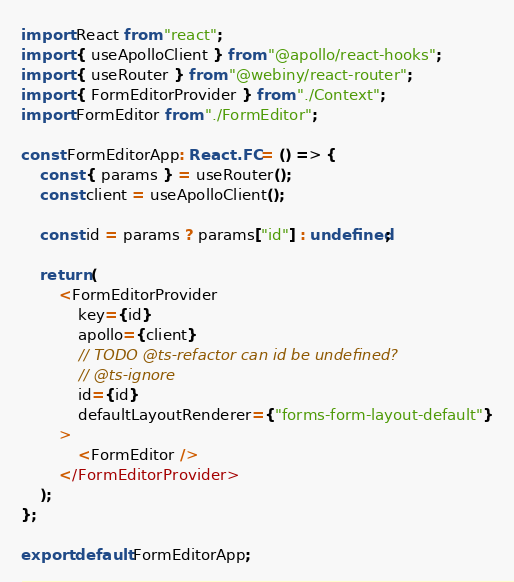Convert code to text. <code><loc_0><loc_0><loc_500><loc_500><_TypeScript_>import React from "react";
import { useApolloClient } from "@apollo/react-hooks";
import { useRouter } from "@webiny/react-router";
import { FormEditorProvider } from "./Context";
import FormEditor from "./FormEditor";

const FormEditorApp: React.FC = () => {
    const { params } = useRouter();
    const client = useApolloClient();

    const id = params ? params["id"] : undefined;

    return (
        <FormEditorProvider
            key={id}
            apollo={client}
            // TODO @ts-refactor can id be undefined?
            // @ts-ignore
            id={id}
            defaultLayoutRenderer={"forms-form-layout-default"}
        >
            <FormEditor />
        </FormEditorProvider>
    );
};

export default FormEditorApp;
</code> 